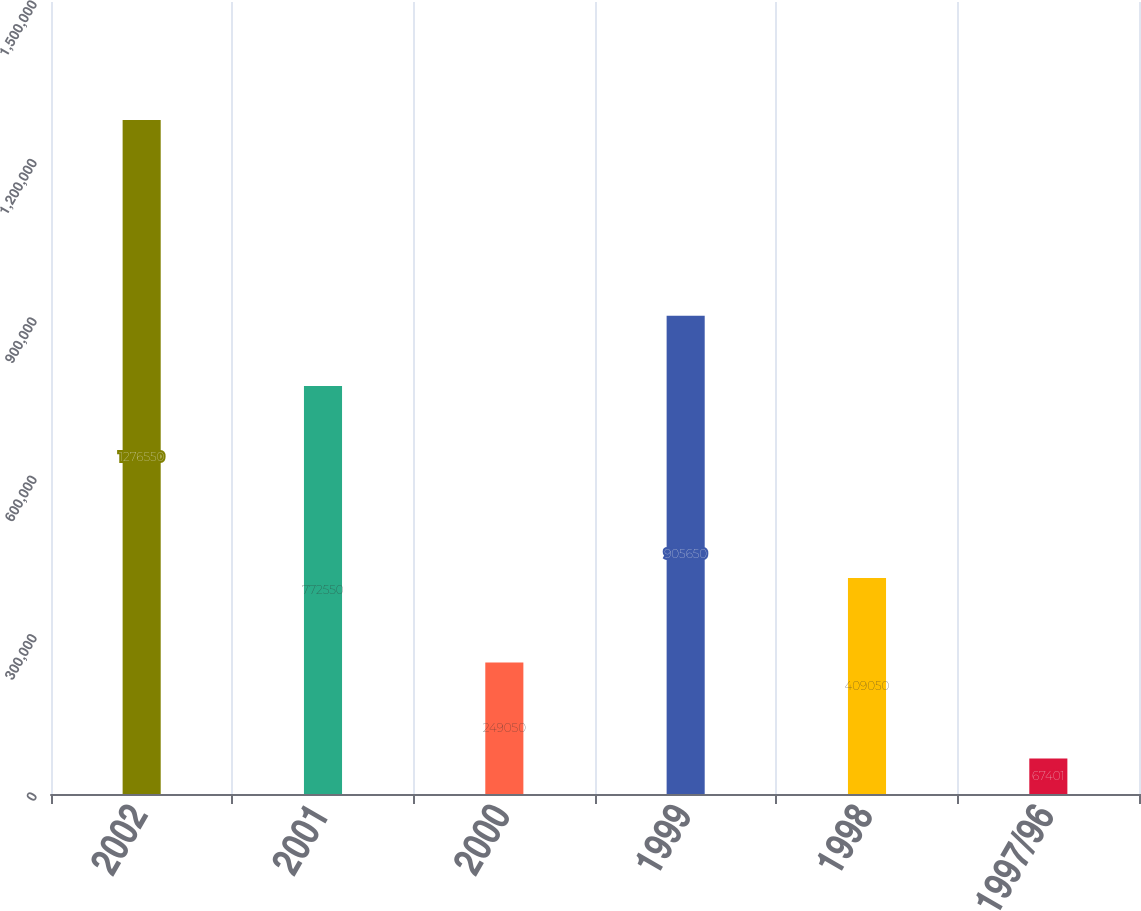Convert chart to OTSL. <chart><loc_0><loc_0><loc_500><loc_500><bar_chart><fcel>2002<fcel>2001<fcel>2000<fcel>1999<fcel>1998<fcel>1997/96<nl><fcel>1.27655e+06<fcel>772550<fcel>249050<fcel>905650<fcel>409050<fcel>67401<nl></chart> 